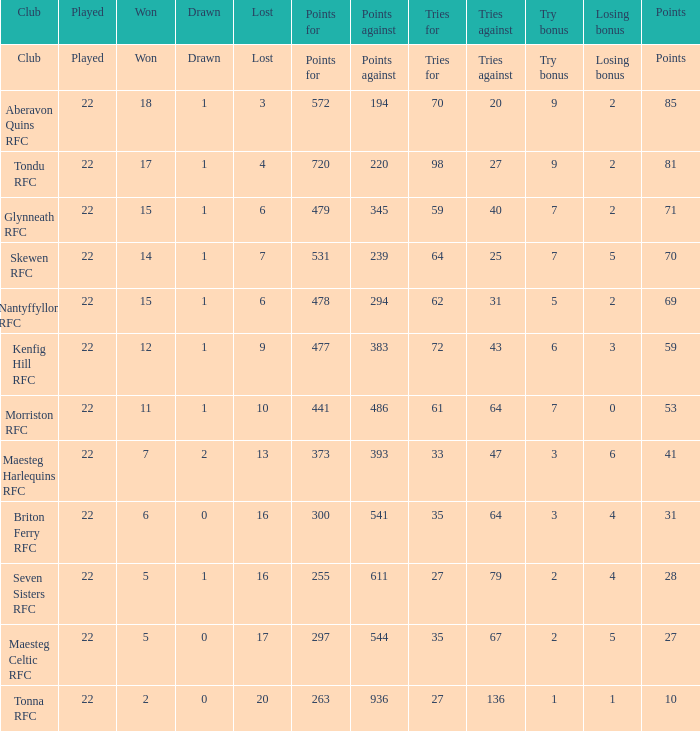What is the value of the points column when the value of the column lost is "lost" Points. 